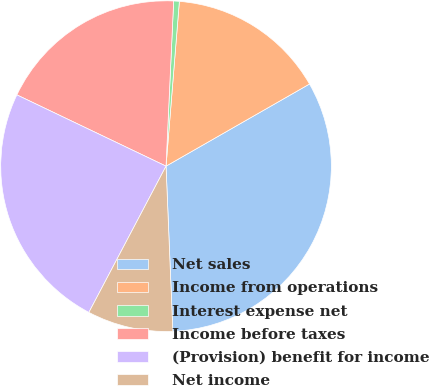Convert chart. <chart><loc_0><loc_0><loc_500><loc_500><pie_chart><fcel>Net sales<fcel>Income from operations<fcel>Interest expense net<fcel>Income before taxes<fcel>(Provision) benefit for income<fcel>Net income<nl><fcel>32.62%<fcel>15.44%<fcel>0.55%<fcel>18.64%<fcel>24.37%<fcel>8.38%<nl></chart> 